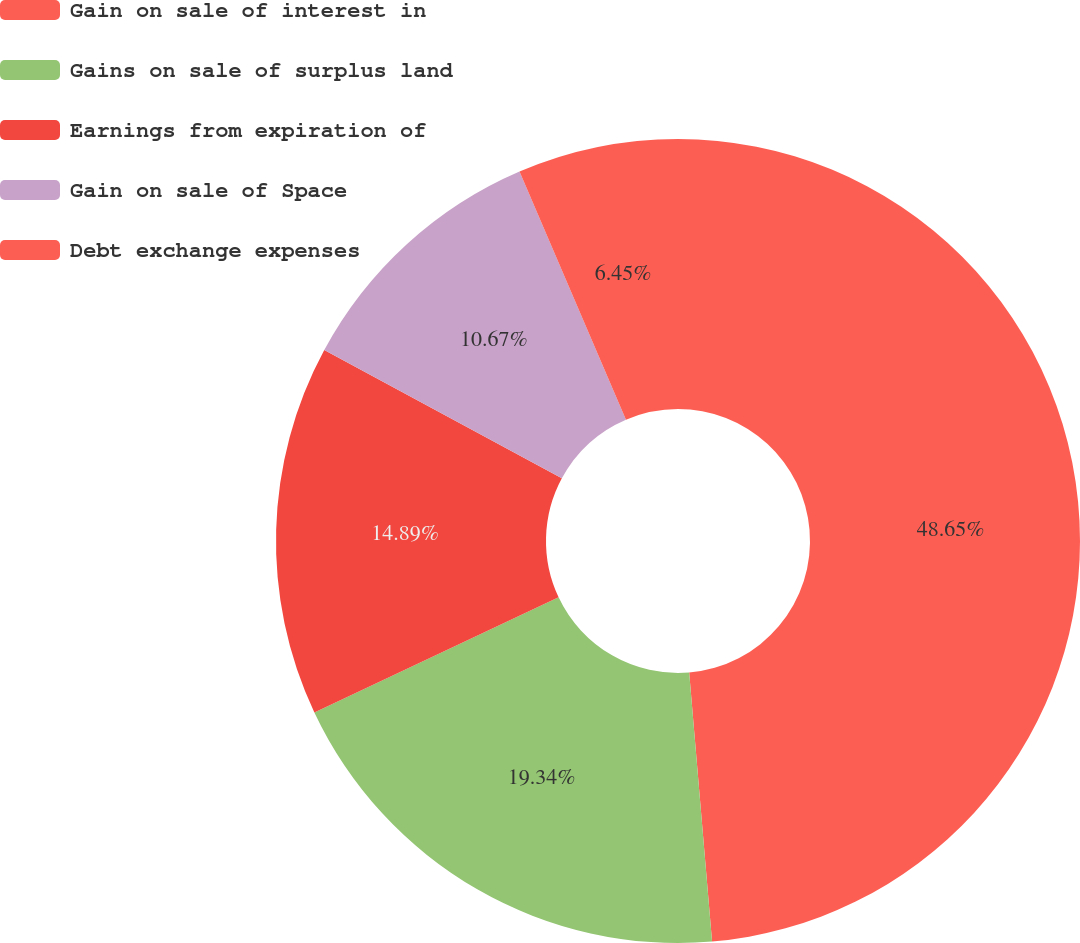Convert chart to OTSL. <chart><loc_0><loc_0><loc_500><loc_500><pie_chart><fcel>Gain on sale of interest in<fcel>Gains on sale of surplus land<fcel>Earnings from expiration of<fcel>Gain on sale of Space<fcel>Debt exchange expenses<nl><fcel>48.65%<fcel>19.34%<fcel>14.89%<fcel>10.67%<fcel>6.45%<nl></chart> 